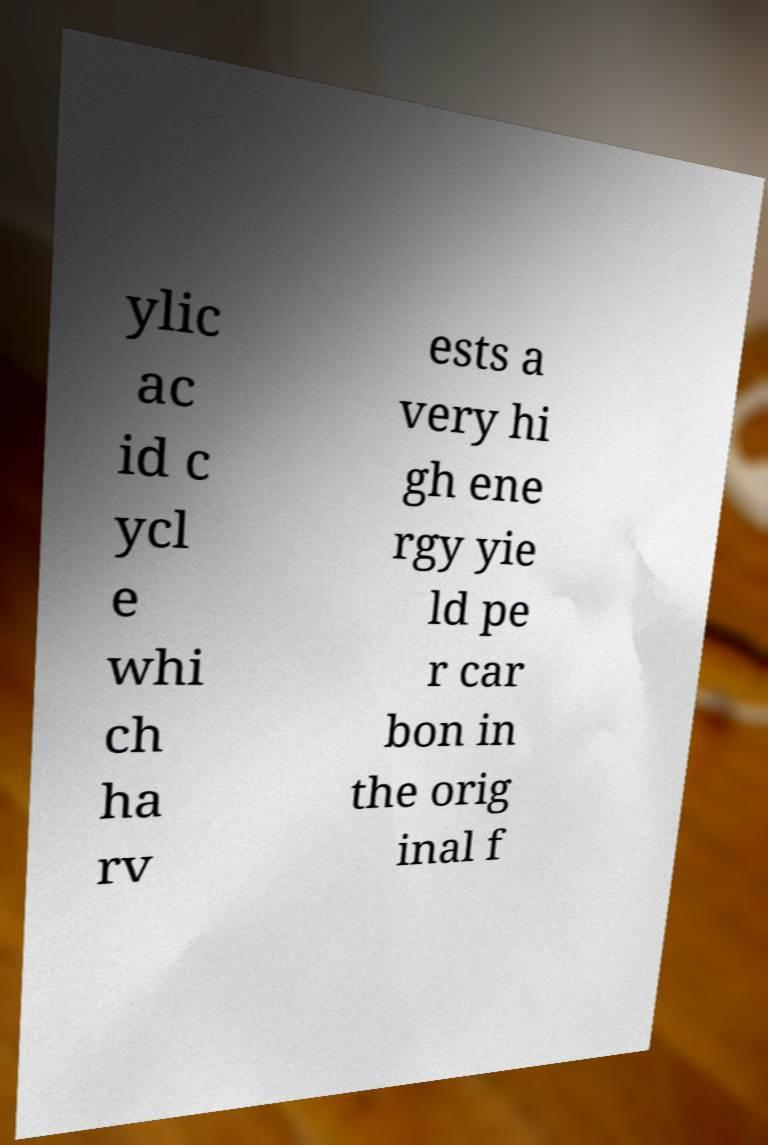I need the written content from this picture converted into text. Can you do that? ylic ac id c ycl e whi ch ha rv ests a very hi gh ene rgy yie ld pe r car bon in the orig inal f 